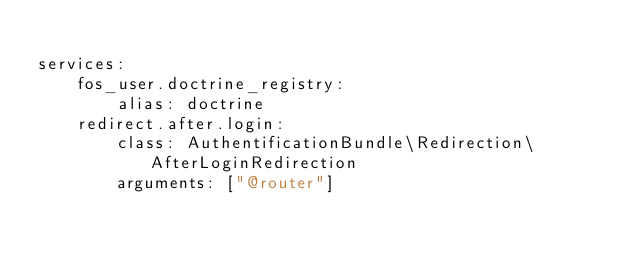<code> <loc_0><loc_0><loc_500><loc_500><_YAML_>
services:
    fos_user.doctrine_registry:
        alias: doctrine
    redirect.after.login:
        class: AuthentificationBundle\Redirection\AfterLoginRedirection
        arguments: ["@router"]</code> 